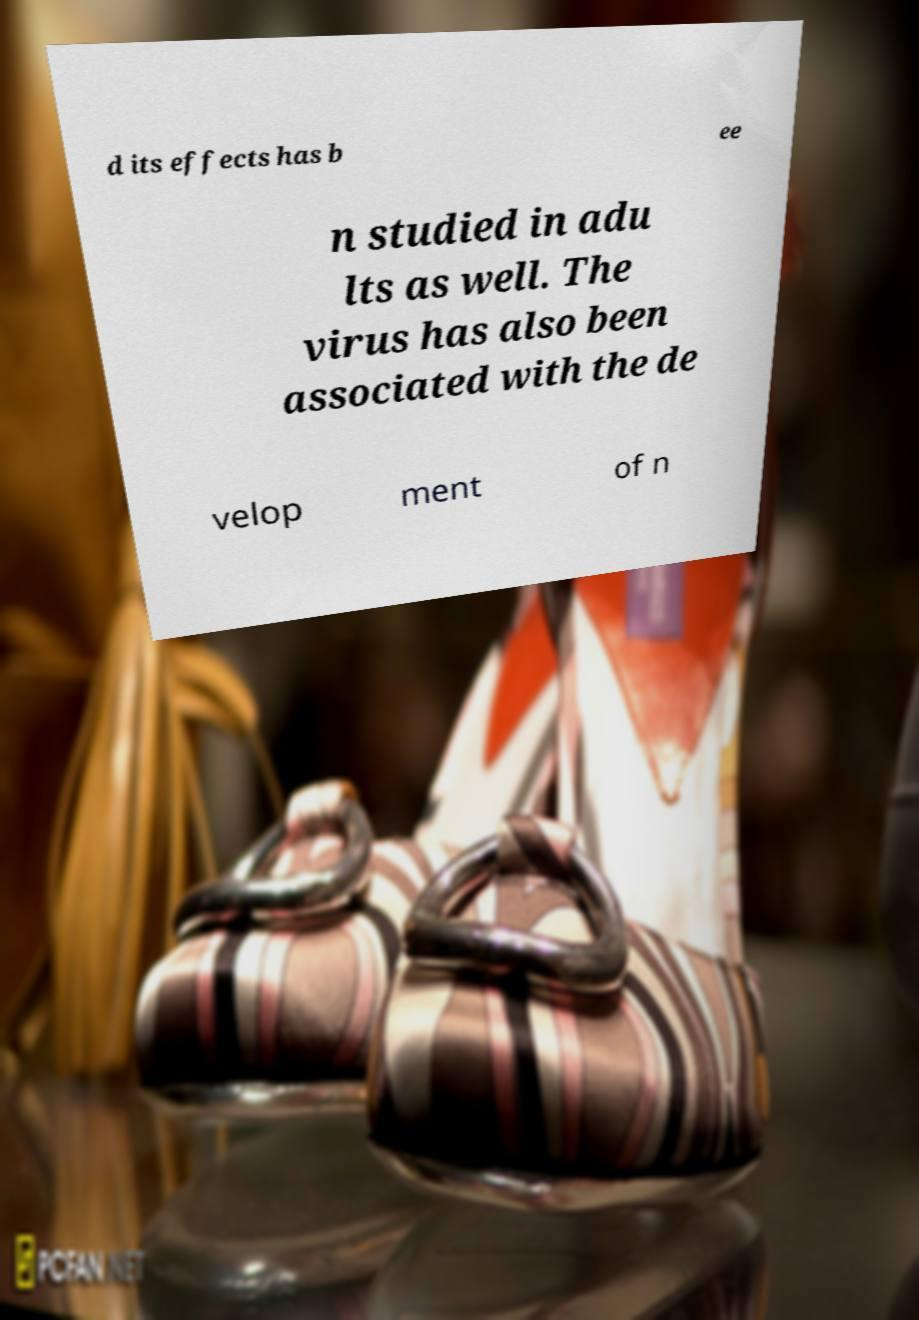Can you accurately transcribe the text from the provided image for me? d its effects has b ee n studied in adu lts as well. The virus has also been associated with the de velop ment of n 